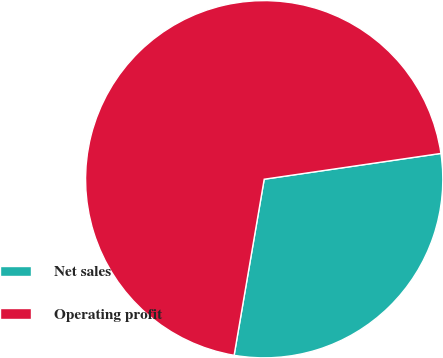Convert chart. <chart><loc_0><loc_0><loc_500><loc_500><pie_chart><fcel>Net sales<fcel>Operating profit<nl><fcel>30.0%<fcel>70.0%<nl></chart> 